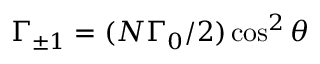<formula> <loc_0><loc_0><loc_500><loc_500>\Gamma _ { \pm 1 } = ( N \Gamma _ { 0 } / 2 ) \cos ^ { 2 } \theta</formula> 